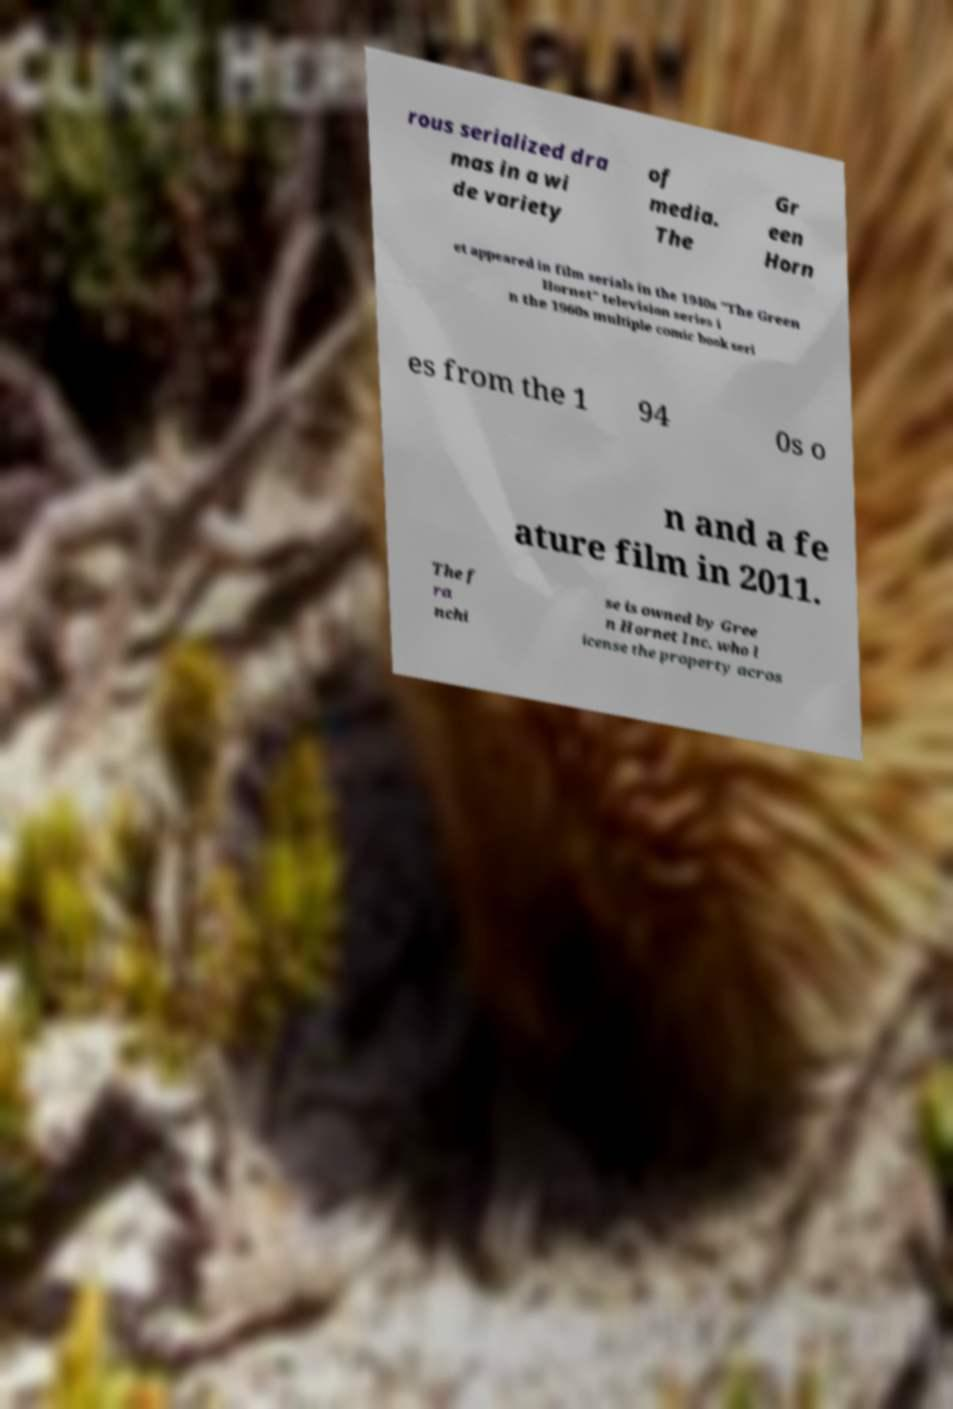Could you extract and type out the text from this image? rous serialized dra mas in a wi de variety of media. The Gr een Horn et appeared in film serials in the 1940s "The Green Hornet" television series i n the 1960s multiple comic book seri es from the 1 94 0s o n and a fe ature film in 2011. The f ra nchi se is owned by Gree n Hornet Inc. who l icense the property acros 